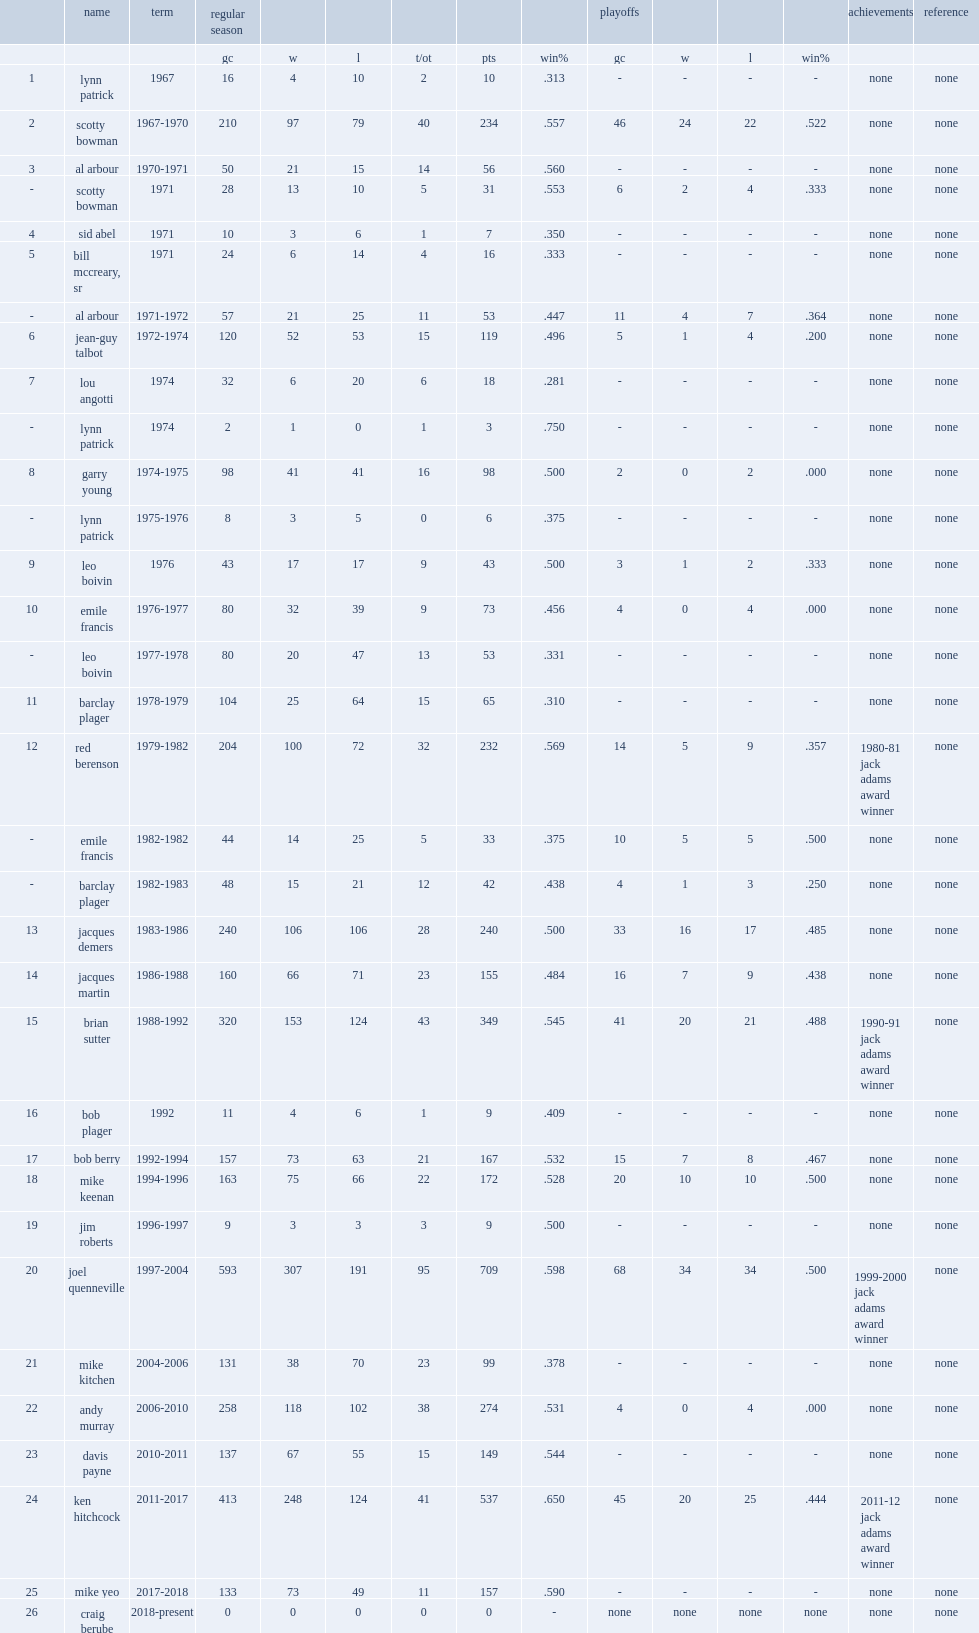Who was the first head coach of the blues in 1967, which was later served by scotty bowman? Lynn patrick. 